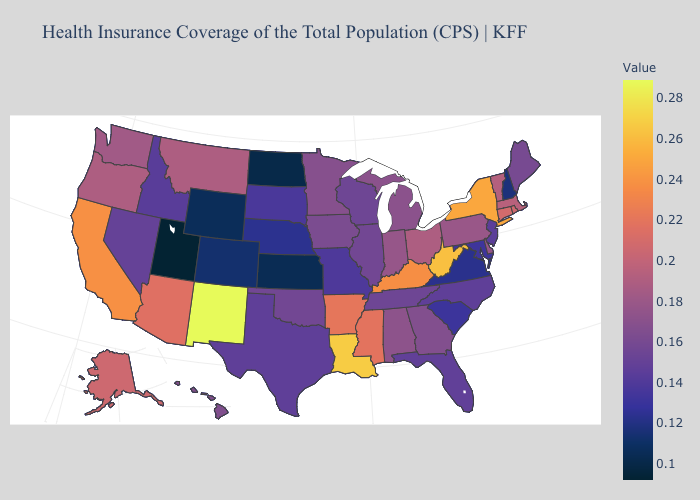Does Kentucky have a lower value than West Virginia?
Short answer required. Yes. Which states have the lowest value in the West?
Quick response, please. Utah. Among the states that border Wisconsin , which have the highest value?
Answer briefly. Michigan. Is the legend a continuous bar?
Answer briefly. Yes. Is the legend a continuous bar?
Keep it brief. Yes. 